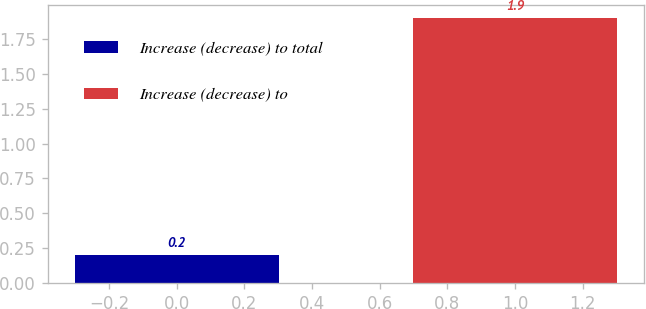Convert chart. <chart><loc_0><loc_0><loc_500><loc_500><bar_chart><fcel>Increase (decrease) to total<fcel>Increase (decrease) to<nl><fcel>0.2<fcel>1.9<nl></chart> 